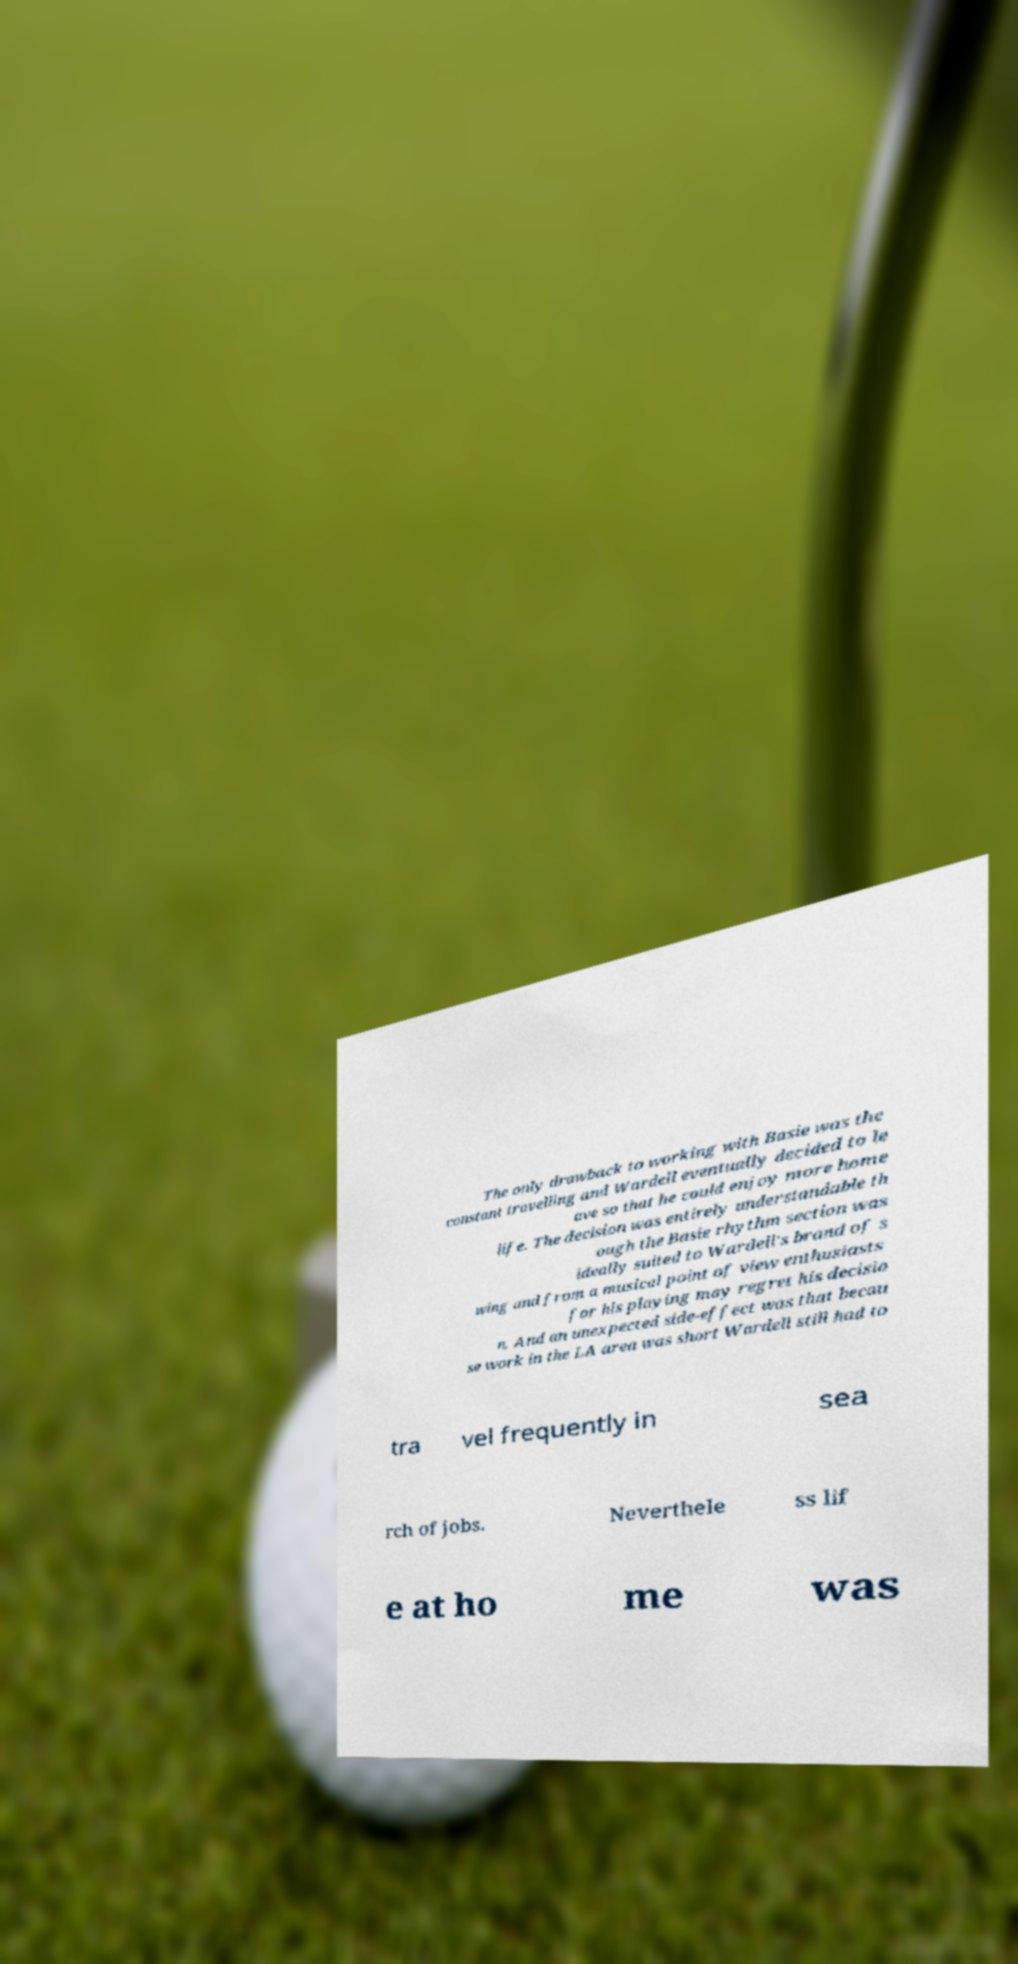Can you accurately transcribe the text from the provided image for me? The only drawback to working with Basie was the constant travelling and Wardell eventually decided to le ave so that he could enjoy more home life. The decision was entirely understandable th ough the Basie rhythm section was ideally suited to Wardell's brand of s wing and from a musical point of view enthusiasts for his playing may regret his decisio n. And an unexpected side-effect was that becau se work in the LA area was short Wardell still had to tra vel frequently in sea rch of jobs. Neverthele ss lif e at ho me was 